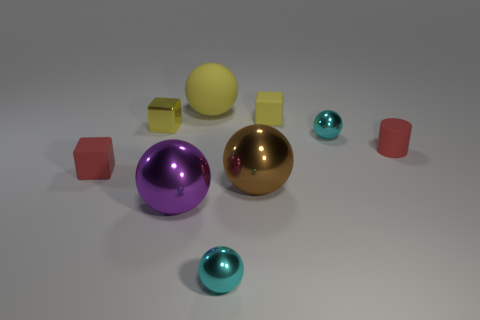What is the shape of the object that is the same color as the small matte cylinder?
Your answer should be very brief. Cube. What size is the red matte object left of the cyan thing in front of the brown sphere?
Your answer should be very brief. Small. The tiny matte cube that is left of the shiny object in front of the metal ball that is left of the big rubber sphere is what color?
Ensure brevity in your answer.  Red. How big is the yellow object that is on the right side of the yellow metal block and in front of the yellow matte ball?
Keep it short and to the point. Small. What number of other objects are there of the same shape as the purple metallic thing?
Keep it short and to the point. 4. What number of blocks are either large objects or small red rubber things?
Offer a terse response. 1. There is a small cube right of the big yellow object that is on the right side of the small red rubber block; is there a cyan sphere left of it?
Your answer should be very brief. Yes. What is the color of the other big rubber thing that is the same shape as the large brown thing?
Make the answer very short. Yellow. How many yellow things are either large rubber objects or small matte objects?
Provide a short and direct response. 2. What is the material of the tiny cyan thing to the right of the matte block that is right of the red matte block?
Your response must be concise. Metal. 